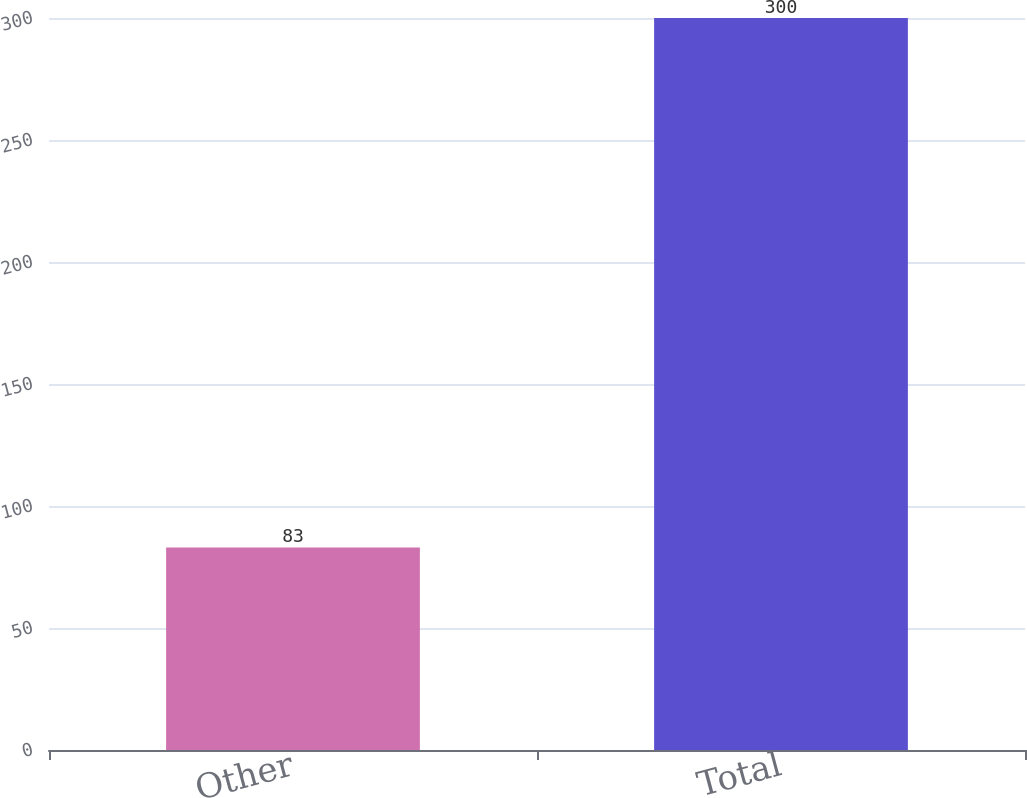Convert chart to OTSL. <chart><loc_0><loc_0><loc_500><loc_500><bar_chart><fcel>Other<fcel>Total<nl><fcel>83<fcel>300<nl></chart> 